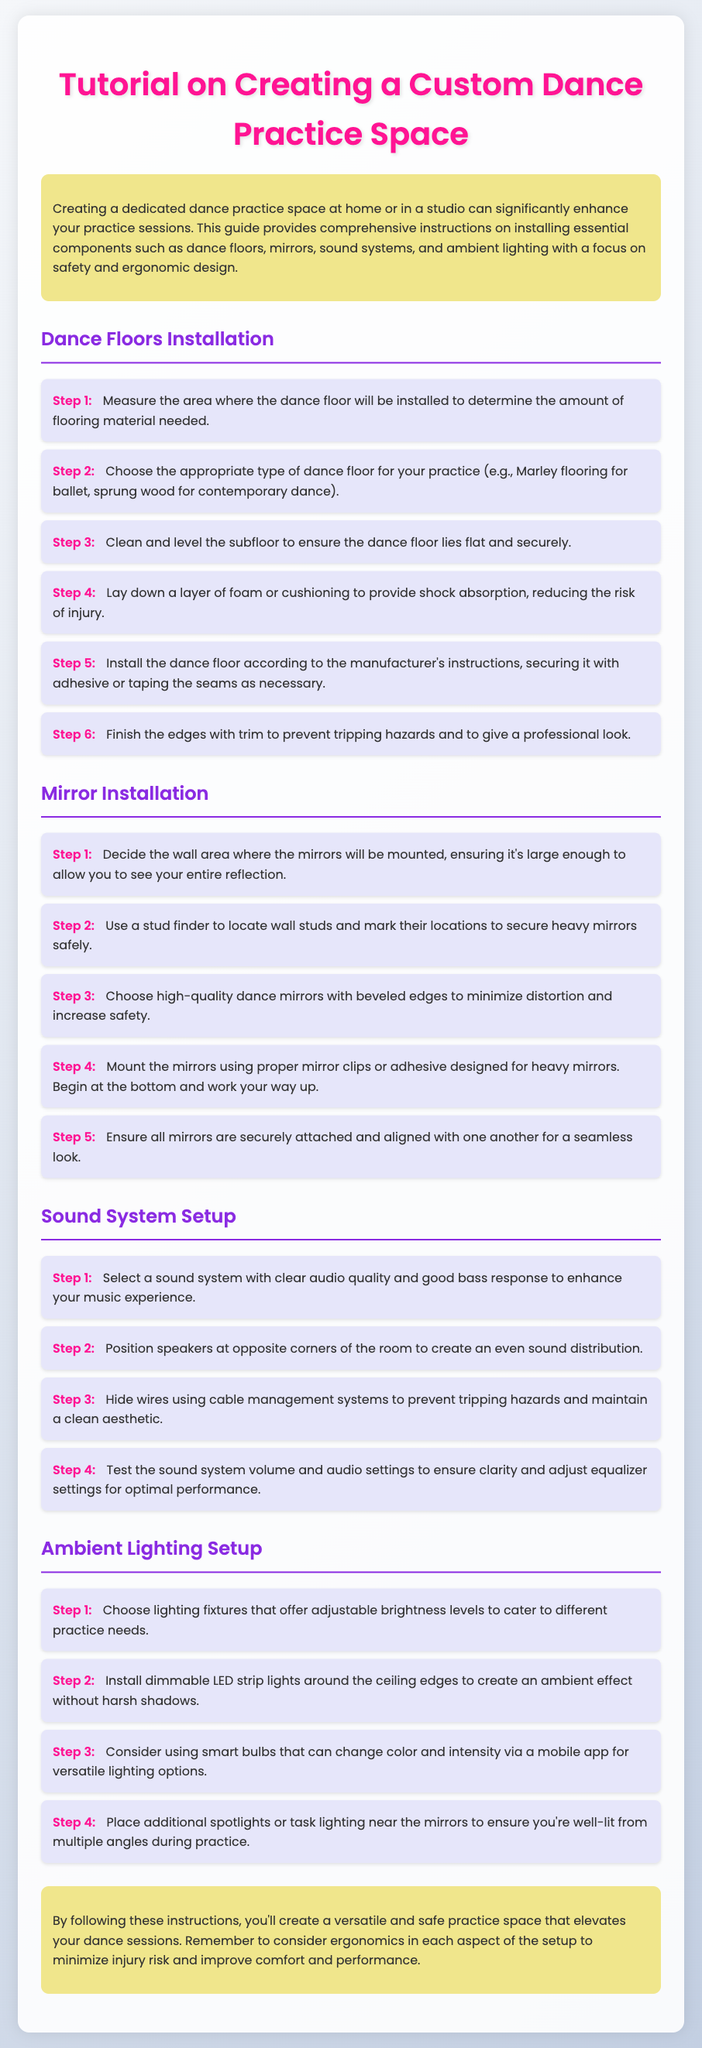What is the purpose of the guide? The guide provides comprehensive instructions on creating a dedicated dance practice space, focusing on installation and safety.
Answer: Enhance practice sessions How many steps are there in the Dance Floors installation section? The Dance Floors section includes a list of steps to follow for installation, which totals six steps.
Answer: 6 What type of lighting should be installed around the ceiling edges? The Ambient Lighting section recommends dimmable LED strip lights for a gentle lighting effect.
Answer: Dimmable LED strip lights What type of flooring is recommended for ballet? The Dance Floors section suggests Marley flooring as the appropriate choice for ballet practice.
Answer: Marley flooring What should be used to secure heavy mirrors? The Mirror Installation steps indicate using proper mirror clips or adhesive designed specifically for heavy mirrors.
Answer: Proper mirror clips or adhesive What audio quality feature should the sound system have? The Sound System Setup section emphasizes selecting a sound system with clear audio quality.
Answer: Clear audio quality What can be used to personalize lighting options? The Ambient Lighting section mentions smart bulbs that can change color and intensity as a versatile solution.
Answer: Smart bulbs What is the main focus when creating the practice space? The guide emphasizes safety and ergonomic design in all aspects of the practice space setup.
Answer: Safety and ergonomic design 